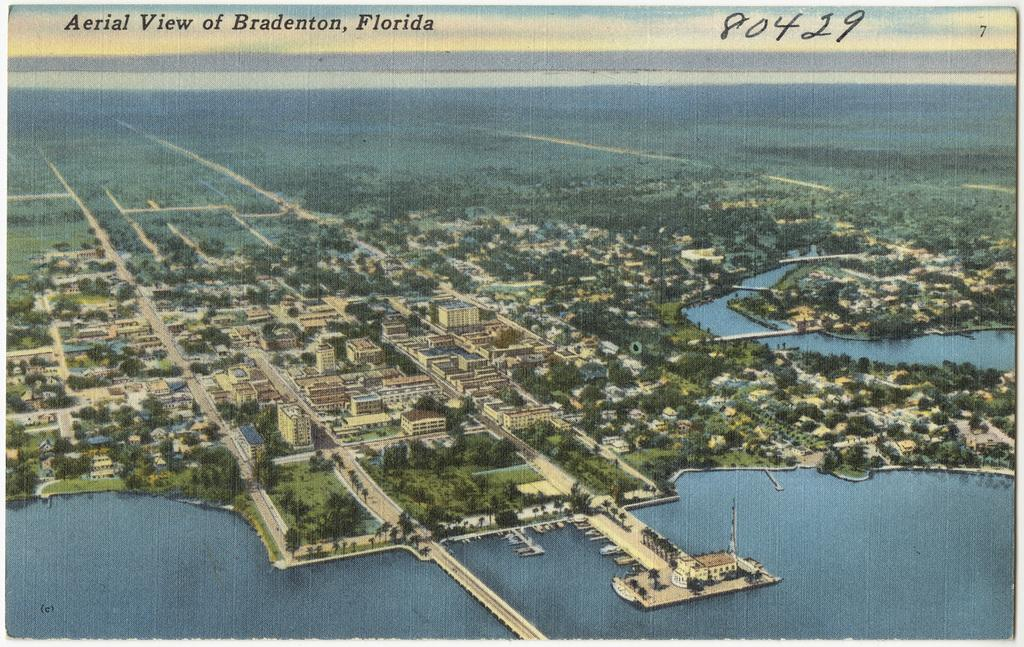What can be seen in the middle of the image? There are buildings, trees, grass, and water in the middle of the image. What type of vegetation is present in the image? Trees and grass are present in the image. What is the nature of the water in the image? The water is visible in the middle of the image. What is written at the top of the image? There is text at the top of the image. How long does the class last in the image? There is no class or duration mentioned in the image. What type of wheel is visible in the image? There is no wheel present in the image. 